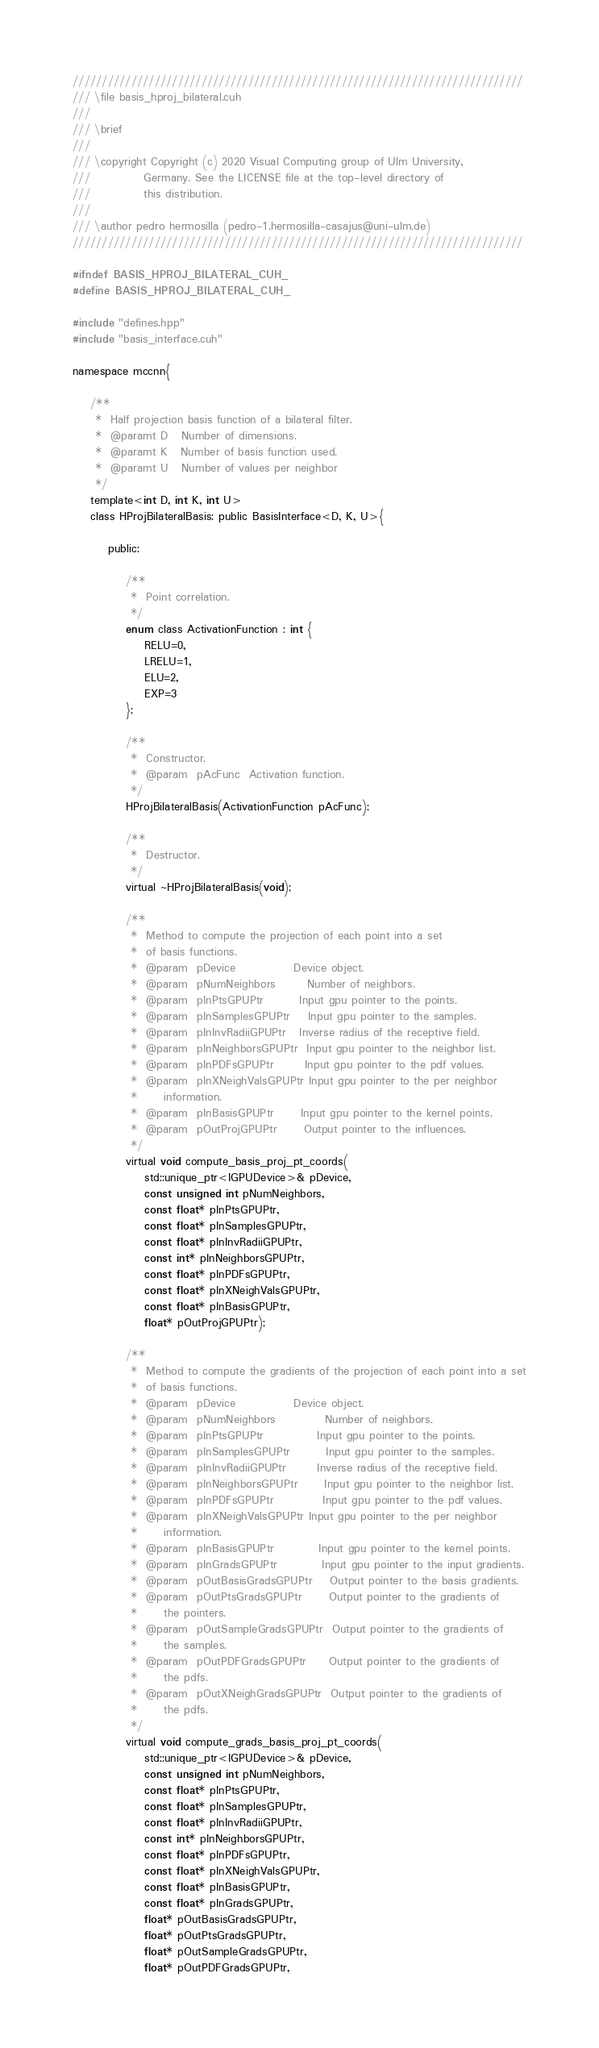<code> <loc_0><loc_0><loc_500><loc_500><_Cuda_>/////////////////////////////////////////////////////////////////////////////
/// \file basis_hproj_bilateral.cuh
///
/// \brief 
///
/// \copyright Copyright (c) 2020 Visual Computing group of Ulm University,  
///            Germany. See the LICENSE file at the top-level directory of 
///            this distribution.
///
/// \author pedro hermosilla (pedro-1.hermosilla-casajus@uni-ulm.de)
/////////////////////////////////////////////////////////////////////////////

#ifndef BASIS_HPROJ_BILATERAL_CUH_
#define BASIS_HPROJ_BILATERAL_CUH_

#include "defines.hpp"
#include "basis_interface.cuh"

namespace mccnn{

    /**
     *  Half projection basis function of a bilateral filter.
     *  @paramt D   Number of dimensions.
     *  @paramt K   Number of basis function used.
     *  @paramt U   Number of values per neighbor
     */
    template<int D, int K, int U>
    class HProjBilateralBasis: public BasisInterface<D, K, U>{
 
        public:

            /**
             *  Point correlation.
             */
            enum class ActivationFunction : int { 
                RELU=0,
                LRELU=1,
                ELU=2,
                EXP=3
            };
 
            /**
             *  Constructor.
             *  @param  pAcFunc  Activation function.
             */
            HProjBilateralBasis(ActivationFunction pAcFunc);
 
            /**
             *  Destructor.
             */
            virtual ~HProjBilateralBasis(void);

            /**
             *  Method to compute the projection of each point into a set
             *  of basis functions.
             *  @param  pDevice             Device object.
             *  @param  pNumNeighbors       Number of neighbors.
             *  @param  pInPtsGPUPtr        Input gpu pointer to the points.
             *  @param  pInSamplesGPUPtr    Input gpu pointer to the samples.
             *  @param  pInInvRadiiGPUPtr   Inverse radius of the receptive field.
             *  @param  pInNeighborsGPUPtr  Input gpu pointer to the neighbor list.
             *  @param  pInPDFsGPUPtr       Input gpu pointer to the pdf values.
             *  @param  pInXNeighValsGPUPtr Input gpu pointer to the per neighbor
             *      information.
             *  @param  pInBasisGPUPtr      Input gpu pointer to the kernel points.
             *  @param  pOutProjGPUPtr      Output pointer to the influences. 
             */
            virtual void compute_basis_proj_pt_coords(
                std::unique_ptr<IGPUDevice>& pDevice,
                const unsigned int pNumNeighbors,       
                const float* pInPtsGPUPtr,
                const float* pInSamplesGPUPtr,
                const float* pInInvRadiiGPUPtr,
                const int* pInNeighborsGPUPtr,
                const float* pInPDFsGPUPtr,
                const float* pInXNeighValsGPUPtr,
                const float* pInBasisGPUPtr,
                float* pOutProjGPUPtr);

            /**
             *  Method to compute the gradients of the projection of each point into a set
             *  of basis functions.
             *  @param  pDevice             Device object.
             *  @param  pNumNeighbors           Number of neighbors.
             *  @param  pInPtsGPUPtr            Input gpu pointer to the points.
             *  @param  pInSamplesGPUPtr        Input gpu pointer to the samples.
             *  @param  pInInvRadiiGPUPtr       Inverse radius of the receptive field.
             *  @param  pInNeighborsGPUPtr      Input gpu pointer to the neighbor list.
             *  @param  pInPDFsGPUPtr           Input gpu pointer to the pdf values.
             *  @param  pInXNeighValsGPUPtr Input gpu pointer to the per neighbor
             *      information.
             *  @param  pInBasisGPUPtr          Input gpu pointer to the kernel points.
             *  @param  pInGradsGPUPtr          Input gpu pointer to the input gradients.
             *  @param  pOutBasisGradsGPUPtr    Output pointer to the basis gradients. 
             *  @param  pOutPtsGradsGPUPtr      Output pointer to the gradients of
             *      the pointers.
             *  @param  pOutSampleGradsGPUPtr  Output pointer to the gradients of
             *      the samples.
             *  @param  pOutPDFGradsGPUPtr     Output pointer to the gradients of
             *      the pdfs.
             *  @param  pOutXNeighGradsGPUPtr  Output pointer to the gradients of
             *      the pdfs.
             */
            virtual void compute_grads_basis_proj_pt_coords(
                std::unique_ptr<IGPUDevice>& pDevice,
                const unsigned int pNumNeighbors,       
                const float* pInPtsGPUPtr,
                const float* pInSamplesGPUPtr,
                const float* pInInvRadiiGPUPtr,
                const int* pInNeighborsGPUPtr,
                const float* pInPDFsGPUPtr,
                const float* pInXNeighValsGPUPtr,
                const float* pInBasisGPUPtr,
                const float* pInGradsGPUPtr,
                float* pOutBasisGradsGPUPtr,
                float* pOutPtsGradsGPUPtr,
                float* pOutSampleGradsGPUPtr,
                float* pOutPDFGradsGPUPtr,</code> 